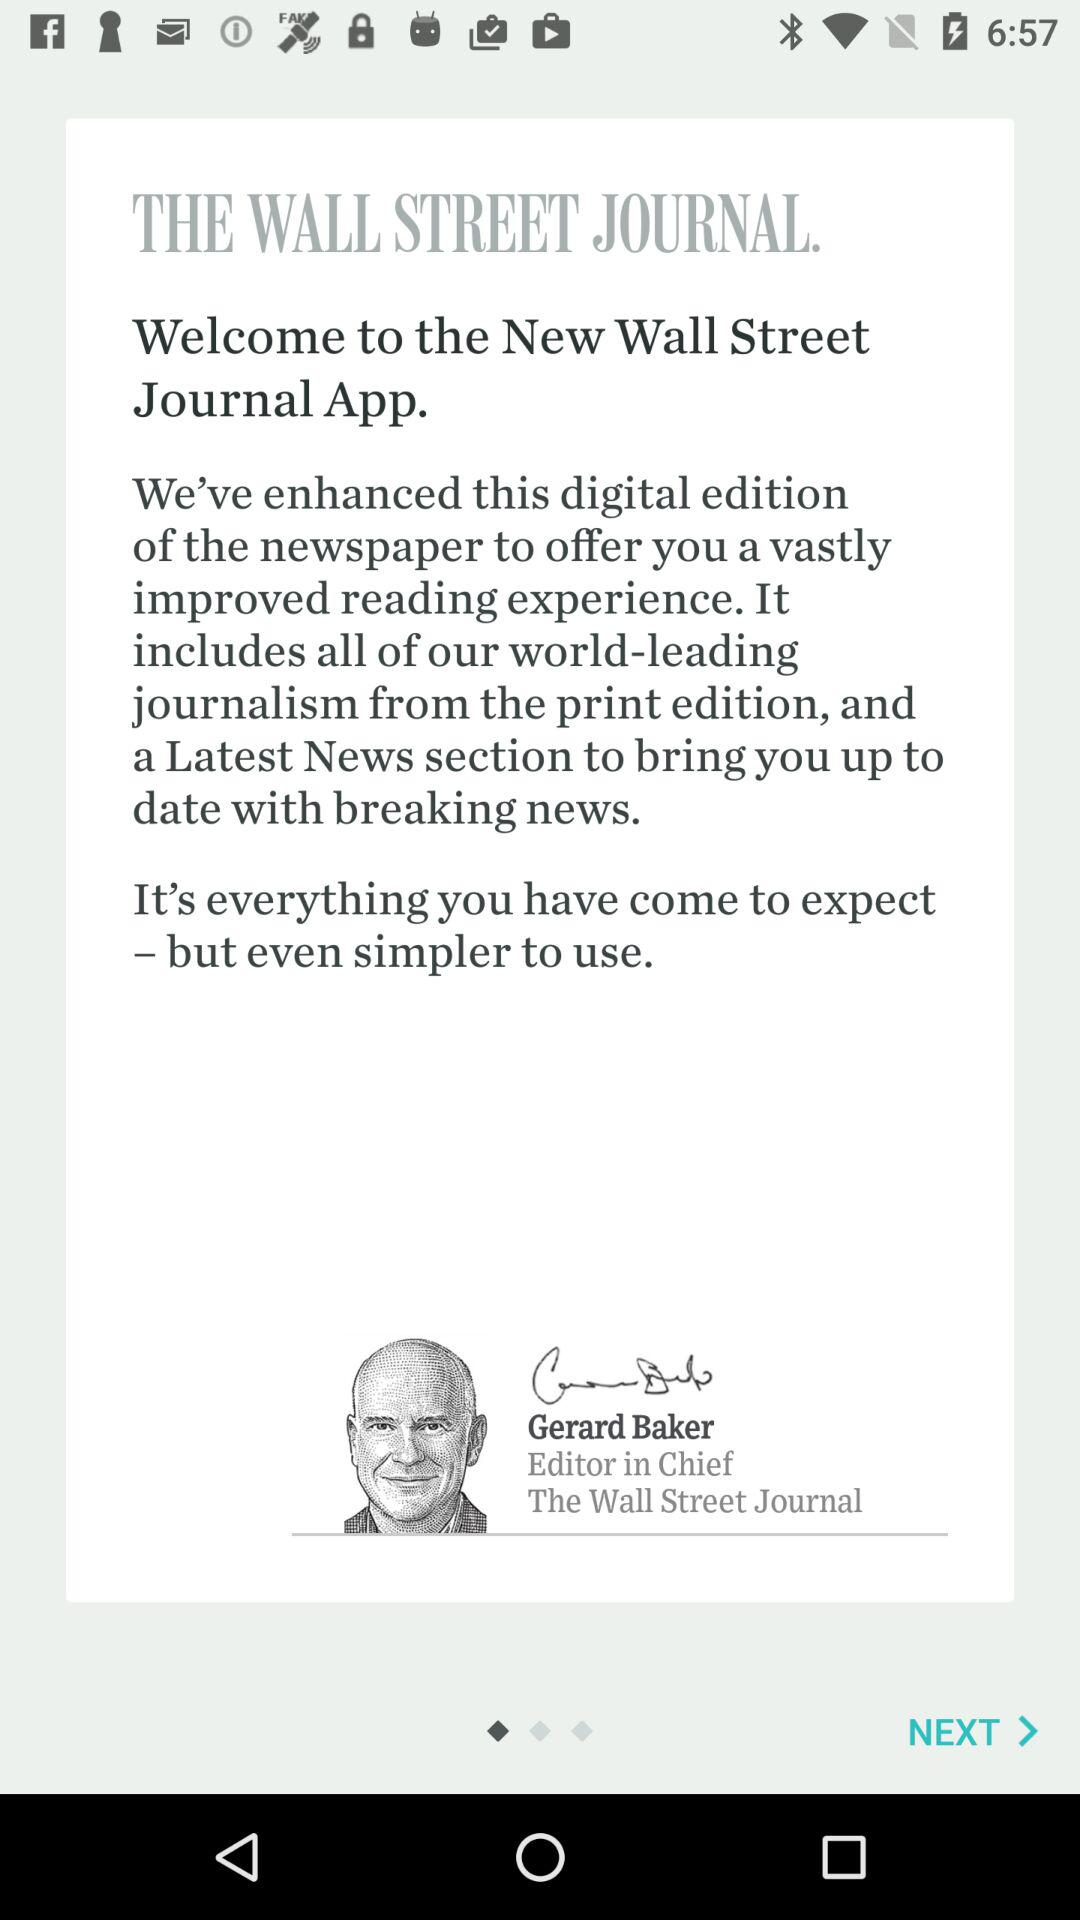What's the editor-in-chief name? The editor-in-chief name is Gerard Baker. 